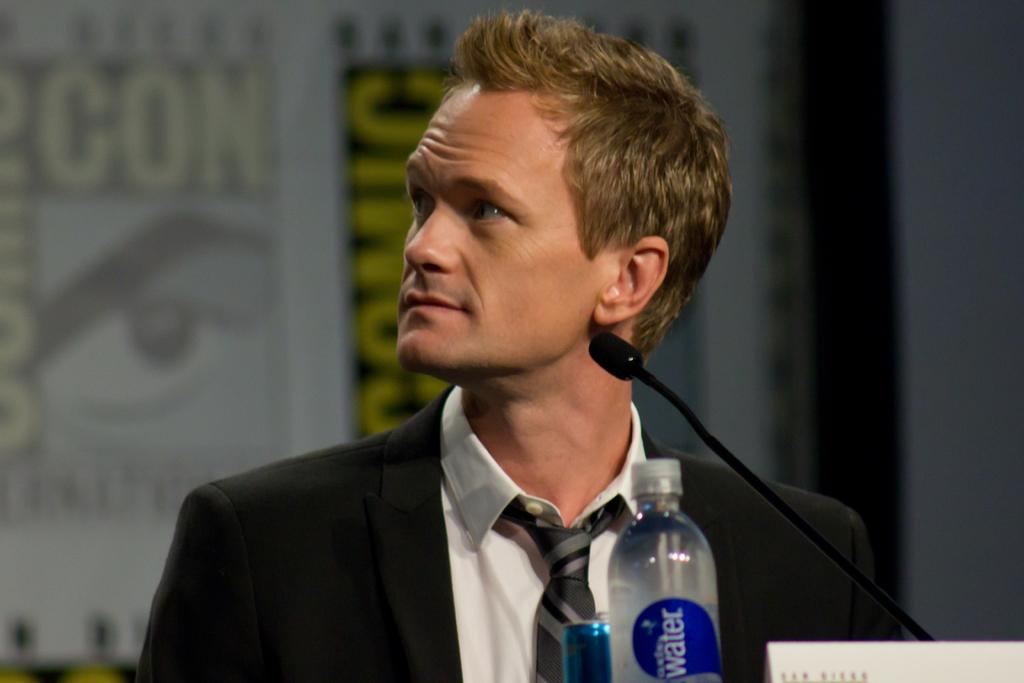Who is present in the image? There is a man in the image. What is the man wearing? The man is wearing a suit. What objects can be seen in the image besides the man? There is a mix, a bottle, and a tin in the image. What type of pet can be seen playing with a jar in the image? There is no pet or jar present in the image. 